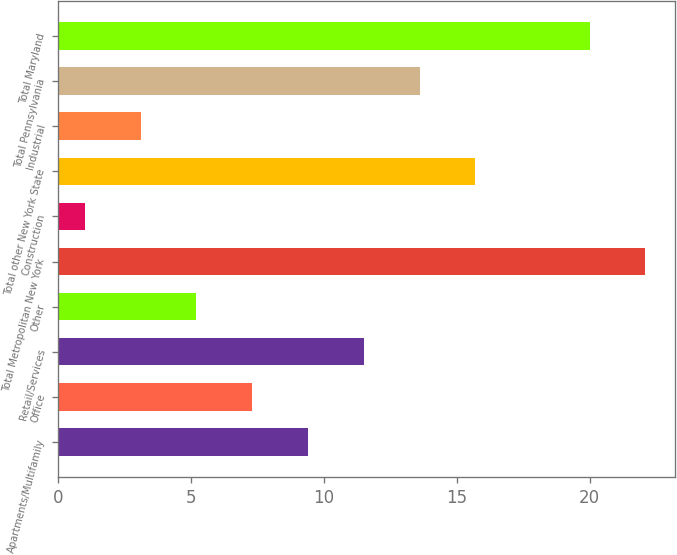<chart> <loc_0><loc_0><loc_500><loc_500><bar_chart><fcel>Apartments/Multifamily<fcel>Office<fcel>Retail/Services<fcel>Other<fcel>Total Metropolitan New York<fcel>Construction<fcel>Total other New York State<fcel>Industrial<fcel>Total Pennsylvania<fcel>Total Maryland<nl><fcel>9.4<fcel>7.3<fcel>11.5<fcel>5.2<fcel>22.1<fcel>1<fcel>15.7<fcel>3.1<fcel>13.6<fcel>20<nl></chart> 